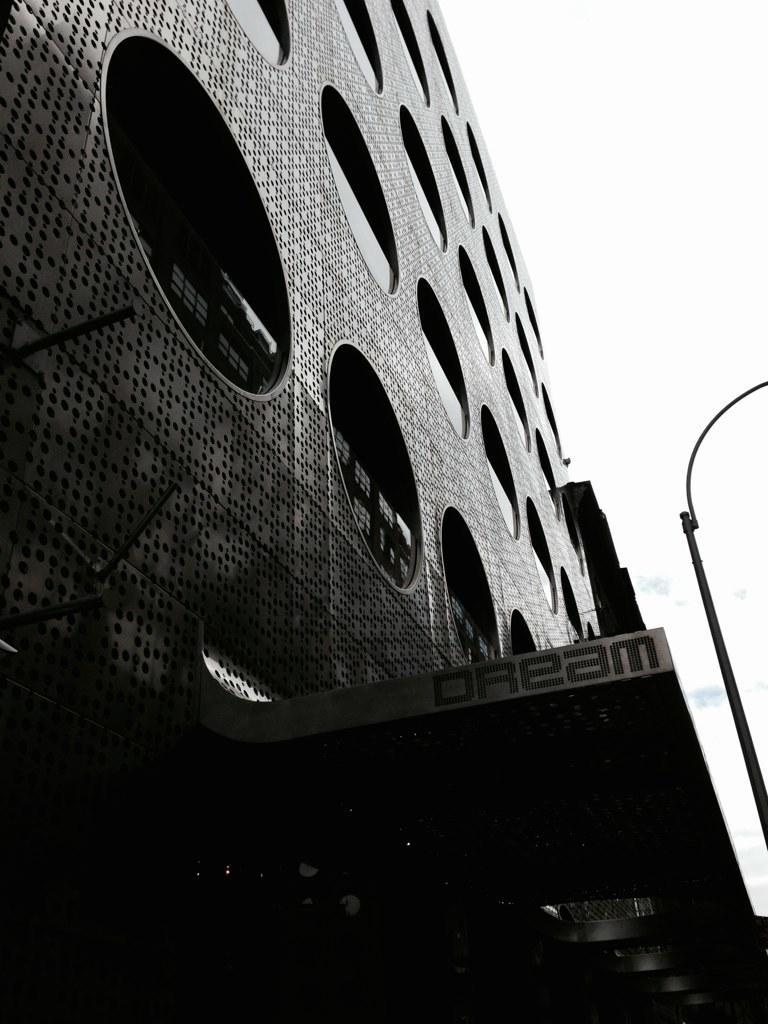How would you summarize this image in a sentence or two? In this image I can see a building,glass windows and pole. The image is in black and white. 